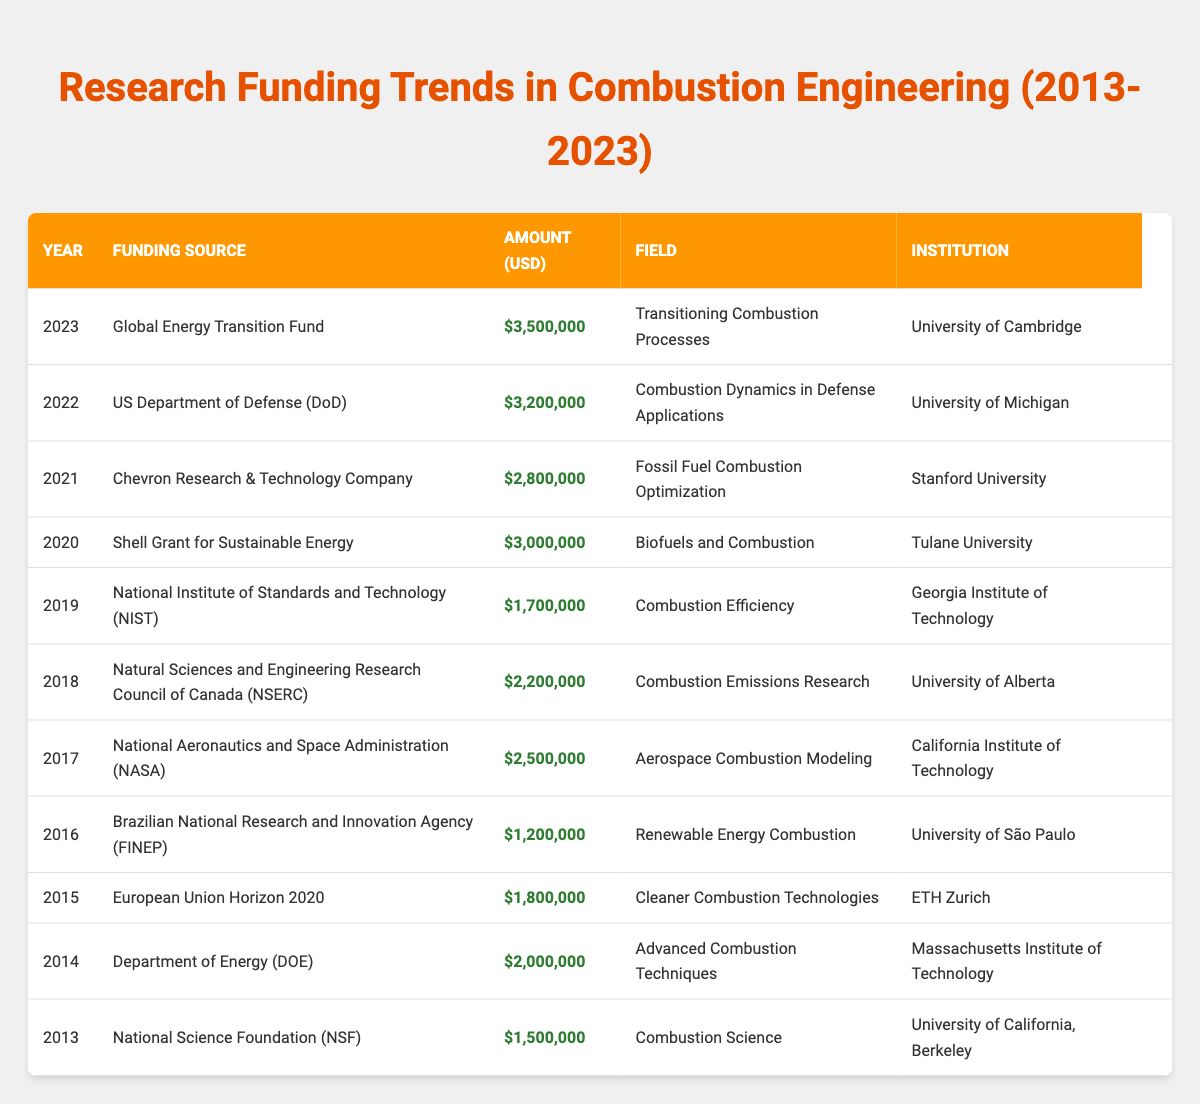What is the highest funding amount recorded in the table? Upon reviewing the table, the highest funding amount can be identified in the year 2023, with the Global Energy Transition Fund providing a total of $3,500,000.
Answer: $3,500,000 Which institution received funding for "Fossil Fuel Combustion Optimization" and in which year? The table lists Stanford University as the institution that received funding for "Fossil Fuel Combustion Optimization" in the year 2021.
Answer: Stanford University, 2021 What was the total funding amount for the years 2019 through 2021? To find the total for the years 2019 through 2021, we take the amounts for those years: $1,700,000 (2019) + $2,800,000 (2021) + $3,000,000 (2020) = $7,500,000.
Answer: $7,500,000 Did the University of California, Berkeley receive more funding than the University of Michigan? Compare the funding amounts: University of California, Berkeley received $1,500,000 (2013) while the University of Michigan received $3,200,000 (2022). Since $1,500,000 is less than $3,200,000, the answer is no.
Answer: No What is the average funding amount over the ten years presented in the table? To calculate the average, we sum all the funding amounts from 2013 to 2023. The total is $21,400,000. Dividing this by the number of entries (11 years), $21,400,000 / 11 = approximately $1,945,454.
Answer: $1,945,454 In which year did the funding from the National Aeronautics and Space Administration (NASA) occur, and what was the amount? The table shows that NASA provided funding in the year 2017 for an amount of $2,500,000.
Answer: 2017, $2,500,000 How does the funding amount in 2020 compare with that in 2016? The table reveals that the funding in 2020 was $3,000,000, while in 2016 it was $1,200,000. Since $3,000,000 is greater than $1,200,000, the 2020 funding was indeed higher than in 2016.
Answer: 2020 was higher What trend can be observed regarding the funding amounts from 2013 to 2023? By looking at the table, it's evident that funding amounts have generally increased over the years: starting at $1,500,000 in 2013 and reaching $3,500,000 in 2023. This indicates a positive trend in research funding for combustion engineering.
Answer: Increasing trend 